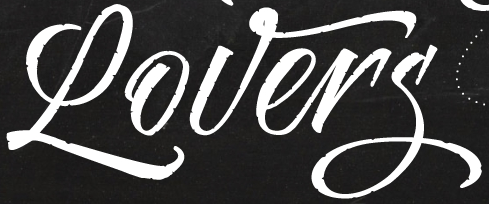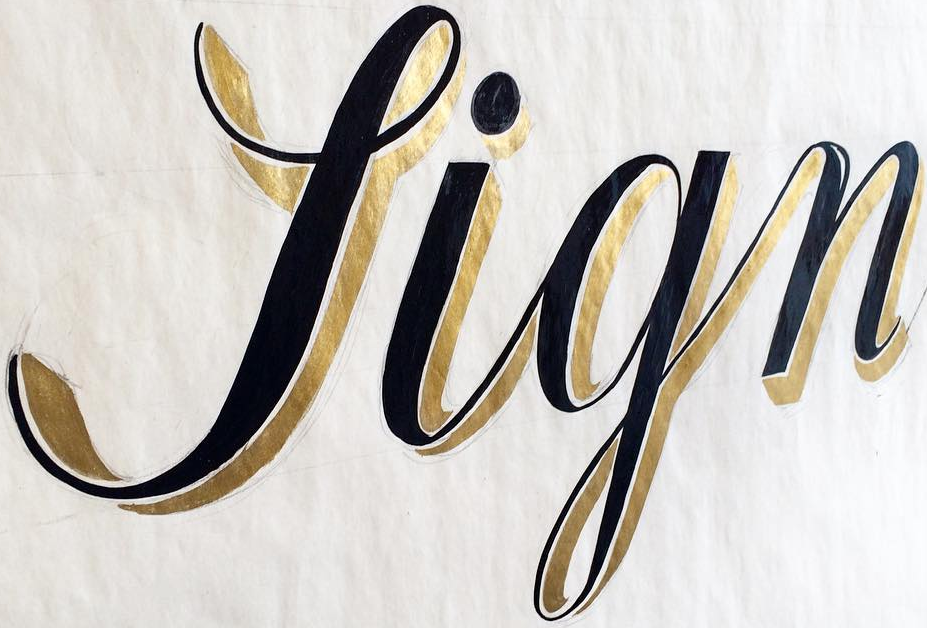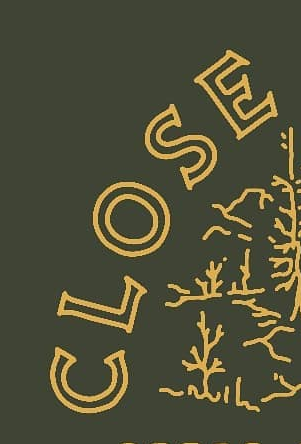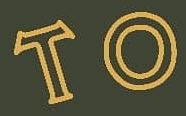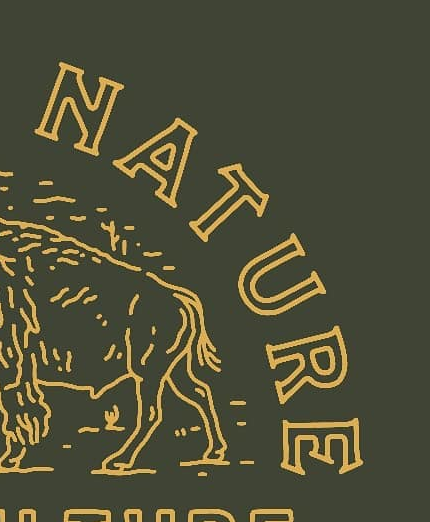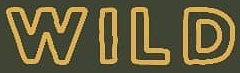What text appears in these images from left to right, separated by a semicolon? Lovers; Sign; CLOSE; TO; NATURE; WILD 